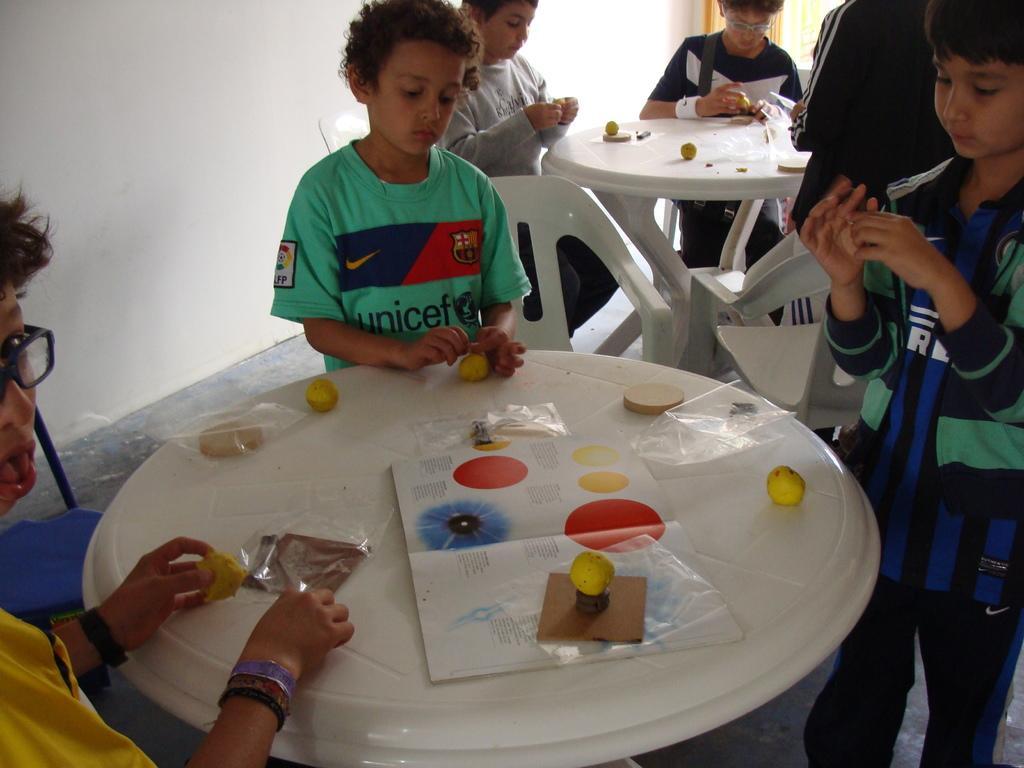Can you describe this image briefly? There are children standing around tables. And there are many chairs. On the table there are some items papers, books. In the background there is a wall. 